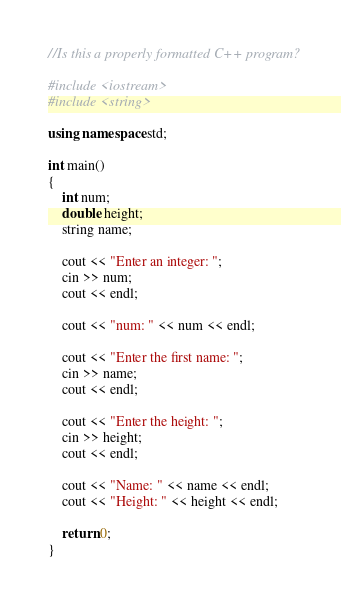Convert code to text. <code><loc_0><loc_0><loc_500><loc_500><_C++_>//Is this a properly formatted C++ program?

#include <iostream>
#include <string>

using namespace std;

int main()
{
    int num;
    double height;
    string name;

    cout << "Enter an integer: ";
    cin >> num;
    cout << endl;

    cout << "num: " << num << endl;

    cout << "Enter the first name: ";
    cin >> name;
    cout << endl;

    cout << "Enter the height: ";
    cin >> height;
    cout << endl;

    cout << "Name: " << name << endl;
    cout << "Height: " << height << endl;

    return 0;
}
</code> 